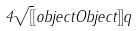Convert formula to latex. <formula><loc_0><loc_0><loc_500><loc_500>4 { \sqrt { [ } [ o b j e c t O b j e c t ] ] { q } }</formula> 